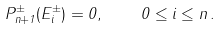<formula> <loc_0><loc_0><loc_500><loc_500>P ^ { \pm } _ { n + 1 } ( E ^ { \pm } _ { i } ) = 0 , \quad 0 \leq i \leq n \, .</formula> 